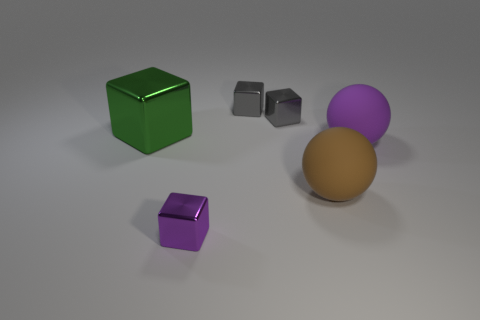There is a purple object in front of the purple thing that is behind the tiny block that is in front of the green cube; what size is it?
Offer a very short reply. Small. What number of rubber things are either purple blocks or large cyan blocks?
Offer a very short reply. 0. There is a tiny purple metal object; does it have the same shape as the large green thing left of the big brown sphere?
Make the answer very short. Yes. Are there more shiny things behind the big green thing than small purple metallic objects that are behind the tiny purple metallic cube?
Ensure brevity in your answer.  Yes. Are there any other things of the same color as the large block?
Keep it short and to the point. No. There is a large thing on the left side of the purple thing that is in front of the brown rubber thing; is there a green cube that is left of it?
Ensure brevity in your answer.  No. There is a small object in front of the big green block; is its shape the same as the large green metal object?
Offer a very short reply. Yes. Is the number of big brown objects on the left side of the brown thing less than the number of large brown rubber objects behind the purple metallic cube?
Keep it short and to the point. Yes. What is the material of the large brown object?
Keep it short and to the point. Rubber. How many brown rubber spheres are in front of the big brown sphere?
Your answer should be very brief. 0. 